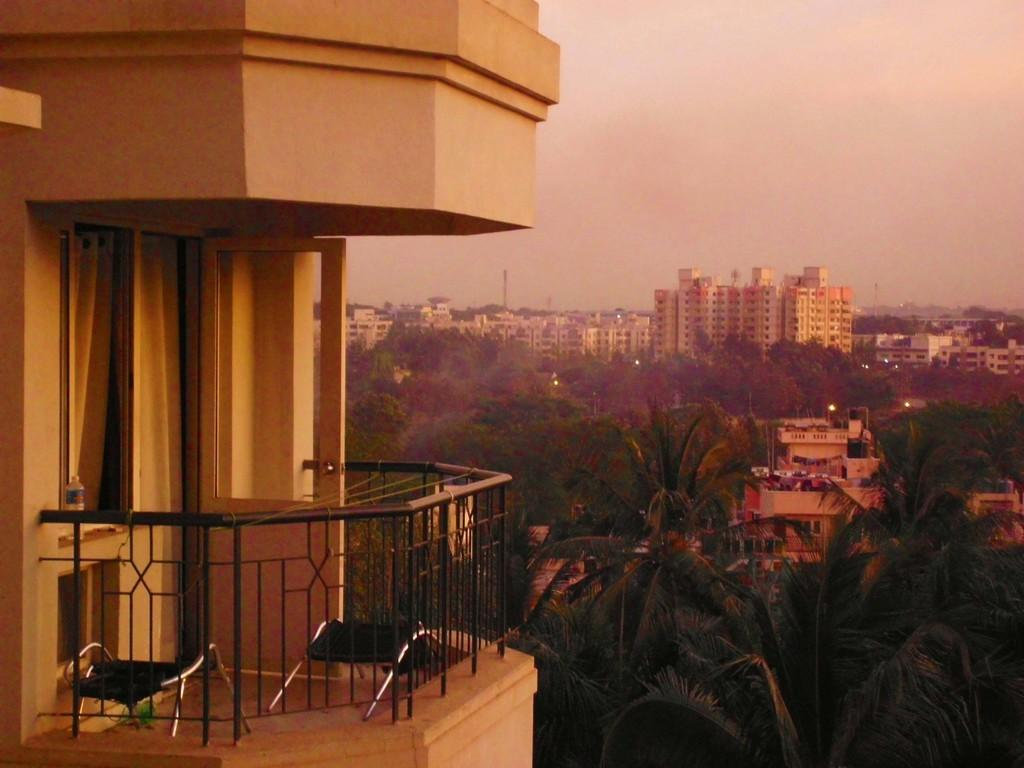What structure is located in the left corner of the image? There is a balcony of a building in the left corner of the image. What can be seen in the background of the image? There are trees and buildings in the background of the image. What type of bucket is being used to serve the meal on the balcony? There is no bucket or meal present on the balcony in the image. 